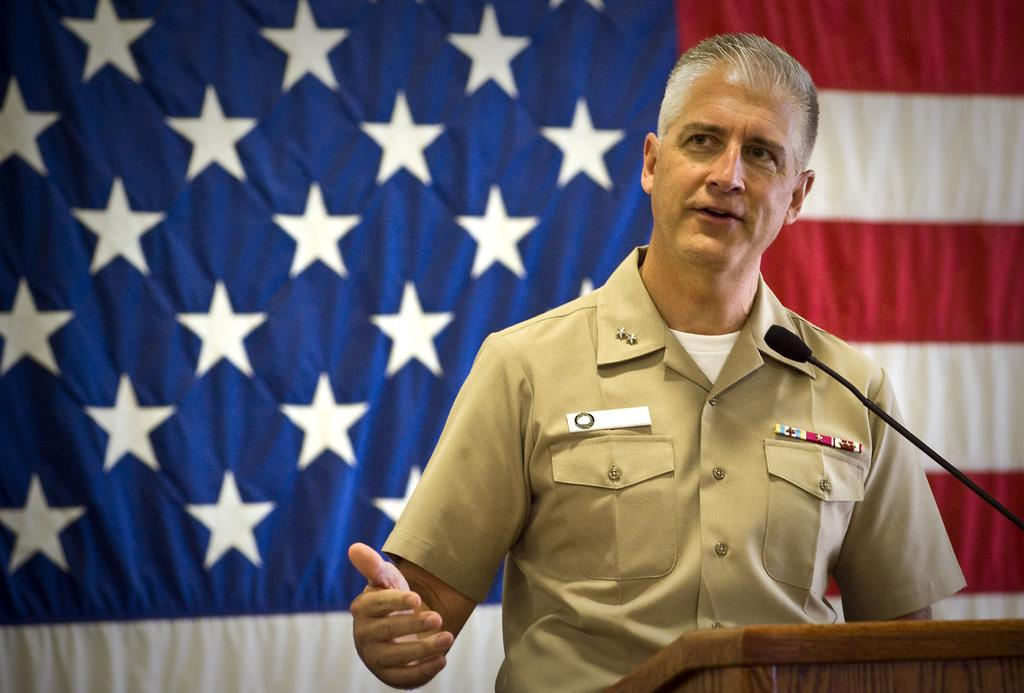Who is the main subject in the image? There is a man in the image. What is the man doing in the image? The man is standing at a podium and speaking with the help of a microphone. What can be seen in the background of the image? There is a flag visible in the image. What is the man wearing that indicates his affiliation or position? The man has badges on his shirt. What type of rock is the man trying to crush with his bare hands in the image? There is no rock present in the image, and the man is not attempting to crush anything with his hands. Can you see a donkey in the image? No, there is no donkey present in the image. 